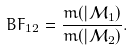Convert formula to latex. <formula><loc_0><loc_0><loc_500><loc_500>B F _ { 1 2 } = \frac { m ( | \mathcal { M } _ { 1 } ) } { m ( | \mathcal { M } _ { 2 } ) } .</formula> 